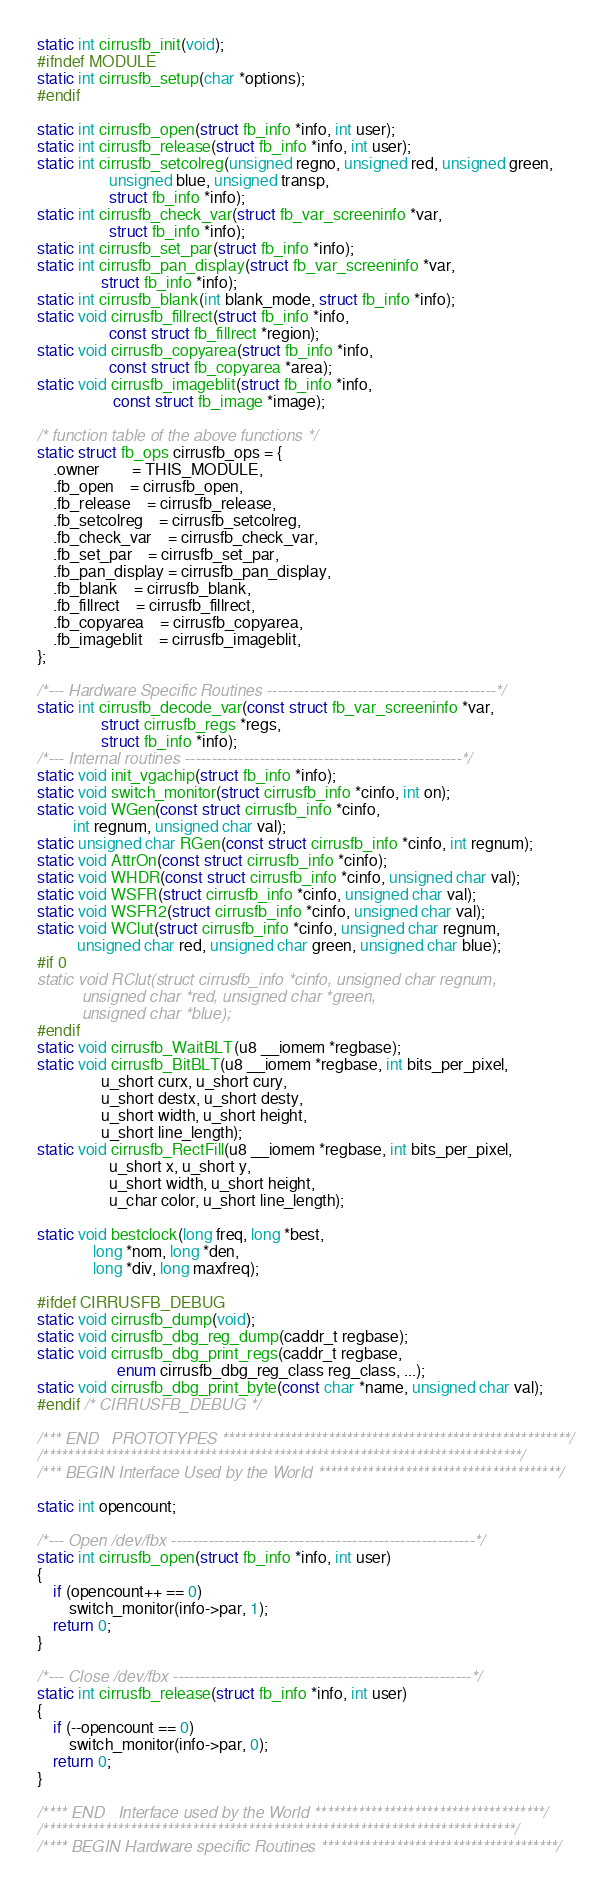Convert code to text. <code><loc_0><loc_0><loc_500><loc_500><_C_>static int cirrusfb_init(void);
#ifndef MODULE
static int cirrusfb_setup(char *options);
#endif

static int cirrusfb_open(struct fb_info *info, int user);
static int cirrusfb_release(struct fb_info *info, int user);
static int cirrusfb_setcolreg(unsigned regno, unsigned red, unsigned green,
			      unsigned blue, unsigned transp,
			      struct fb_info *info);
static int cirrusfb_check_var(struct fb_var_screeninfo *var,
			      struct fb_info *info);
static int cirrusfb_set_par(struct fb_info *info);
static int cirrusfb_pan_display(struct fb_var_screeninfo *var,
				struct fb_info *info);
static int cirrusfb_blank(int blank_mode, struct fb_info *info);
static void cirrusfb_fillrect(struct fb_info *info,
			      const struct fb_fillrect *region);
static void cirrusfb_copyarea(struct fb_info *info,
			      const struct fb_copyarea *area);
static void cirrusfb_imageblit(struct fb_info *info,
			       const struct fb_image *image);

/* function table of the above functions */
static struct fb_ops cirrusfb_ops = {
	.owner		= THIS_MODULE,
	.fb_open	= cirrusfb_open,
	.fb_release	= cirrusfb_release,
	.fb_setcolreg	= cirrusfb_setcolreg,
	.fb_check_var	= cirrusfb_check_var,
	.fb_set_par	= cirrusfb_set_par,
	.fb_pan_display = cirrusfb_pan_display,
	.fb_blank	= cirrusfb_blank,
	.fb_fillrect	= cirrusfb_fillrect,
	.fb_copyarea	= cirrusfb_copyarea,
	.fb_imageblit	= cirrusfb_imageblit,
};

/*--- Hardware Specific Routines -------------------------------------------*/
static int cirrusfb_decode_var(const struct fb_var_screeninfo *var,
				struct cirrusfb_regs *regs,
				struct fb_info *info);
/*--- Internal routines ----------------------------------------------------*/
static void init_vgachip(struct fb_info *info);
static void switch_monitor(struct cirrusfb_info *cinfo, int on);
static void WGen(const struct cirrusfb_info *cinfo,
		 int regnum, unsigned char val);
static unsigned char RGen(const struct cirrusfb_info *cinfo, int regnum);
static void AttrOn(const struct cirrusfb_info *cinfo);
static void WHDR(const struct cirrusfb_info *cinfo, unsigned char val);
static void WSFR(struct cirrusfb_info *cinfo, unsigned char val);
static void WSFR2(struct cirrusfb_info *cinfo, unsigned char val);
static void WClut(struct cirrusfb_info *cinfo, unsigned char regnum,
		  unsigned char red, unsigned char green, unsigned char blue);
#if 0
static void RClut(struct cirrusfb_info *cinfo, unsigned char regnum,
		  unsigned char *red, unsigned char *green,
		  unsigned char *blue);
#endif
static void cirrusfb_WaitBLT(u8 __iomem *regbase);
static void cirrusfb_BitBLT(u8 __iomem *regbase, int bits_per_pixel,
			    u_short curx, u_short cury,
			    u_short destx, u_short desty,
			    u_short width, u_short height,
			    u_short line_length);
static void cirrusfb_RectFill(u8 __iomem *regbase, int bits_per_pixel,
			      u_short x, u_short y,
			      u_short width, u_short height,
			      u_char color, u_short line_length);

static void bestclock(long freq, long *best,
		      long *nom, long *den,
		      long *div, long maxfreq);

#ifdef CIRRUSFB_DEBUG
static void cirrusfb_dump(void);
static void cirrusfb_dbg_reg_dump(caddr_t regbase);
static void cirrusfb_dbg_print_regs(caddr_t regbase,
				    enum cirrusfb_dbg_reg_class reg_class, ...);
static void cirrusfb_dbg_print_byte(const char *name, unsigned char val);
#endif /* CIRRUSFB_DEBUG */

/*** END   PROTOTYPES ********************************************************/
/*****************************************************************************/
/*** BEGIN Interface Used by the World ***************************************/

static int opencount;

/*--- Open /dev/fbx ---------------------------------------------------------*/
static int cirrusfb_open(struct fb_info *info, int user)
{
	if (opencount++ == 0)
		switch_monitor(info->par, 1);
	return 0;
}

/*--- Close /dev/fbx --------------------------------------------------------*/
static int cirrusfb_release(struct fb_info *info, int user)
{
	if (--opencount == 0)
		switch_monitor(info->par, 0);
	return 0;
}

/**** END   Interface used by the World *************************************/
/****************************************************************************/
/**** BEGIN Hardware specific Routines **************************************/
</code> 